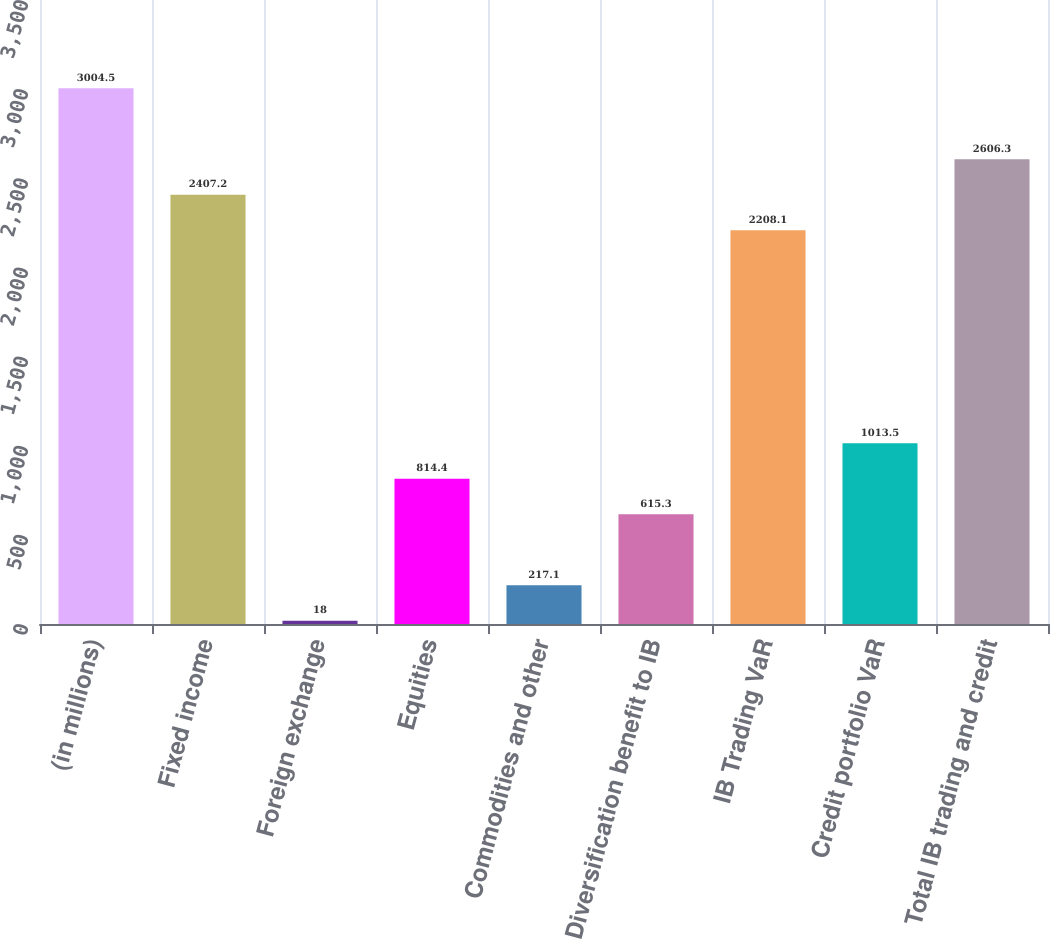<chart> <loc_0><loc_0><loc_500><loc_500><bar_chart><fcel>(in millions)<fcel>Fixed income<fcel>Foreign exchange<fcel>Equities<fcel>Commodities and other<fcel>Diversification benefit to IB<fcel>IB Trading VaR<fcel>Credit portfolio VaR<fcel>Total IB trading and credit<nl><fcel>3004.5<fcel>2407.2<fcel>18<fcel>814.4<fcel>217.1<fcel>615.3<fcel>2208.1<fcel>1013.5<fcel>2606.3<nl></chart> 